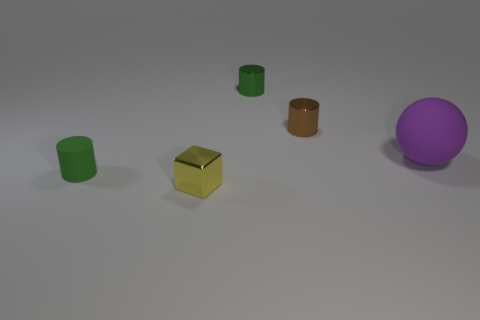What size is the cylinder that is the same color as the small matte object?
Offer a terse response. Small. What number of tiny cylinders have the same material as the purple thing?
Provide a succinct answer. 1. There is a shiny thing that is the same color as the small matte thing; what shape is it?
Keep it short and to the point. Cylinder. There is a green cylinder that is behind the large purple matte thing that is in front of the brown shiny object; what size is it?
Offer a terse response. Small. Is the shape of the tiny green thing behind the rubber sphere the same as the matte object that is on the left side of the brown metallic cylinder?
Keep it short and to the point. Yes. Are there an equal number of large balls that are to the left of the large purple rubber ball and small yellow metallic blocks?
Ensure brevity in your answer.  No. The other rubber object that is the same shape as the small brown thing is what color?
Provide a short and direct response. Green. Is the green cylinder that is behind the small brown metallic cylinder made of the same material as the brown cylinder?
Your answer should be very brief. Yes. How many tiny objects are brown cylinders or purple balls?
Provide a succinct answer. 1. The rubber sphere has what size?
Offer a very short reply. Large. 